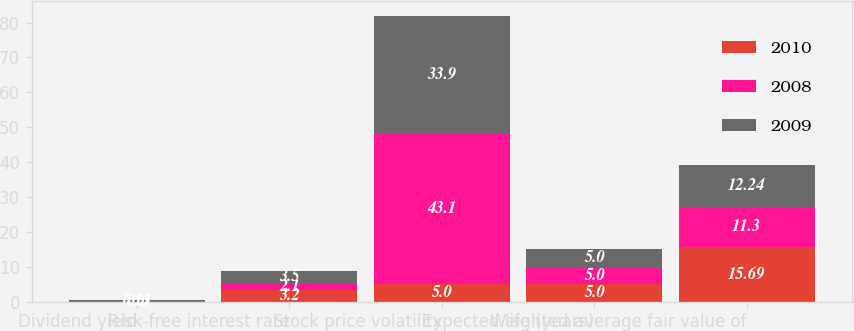Convert chart. <chart><loc_0><loc_0><loc_500><loc_500><stacked_bar_chart><ecel><fcel>Dividend yield<fcel>Risk-free interest rate<fcel>Stock price volatility<fcel>Expected life (years)<fcel>Weighted average fair value of<nl><fcel>2010<fcel>0.1<fcel>3.2<fcel>5<fcel>5<fcel>15.69<nl><fcel>2008<fcel>0.13<fcel>2.1<fcel>43.1<fcel>5<fcel>11.3<nl><fcel>2009<fcel>0.11<fcel>3.5<fcel>33.9<fcel>5<fcel>12.24<nl></chart> 